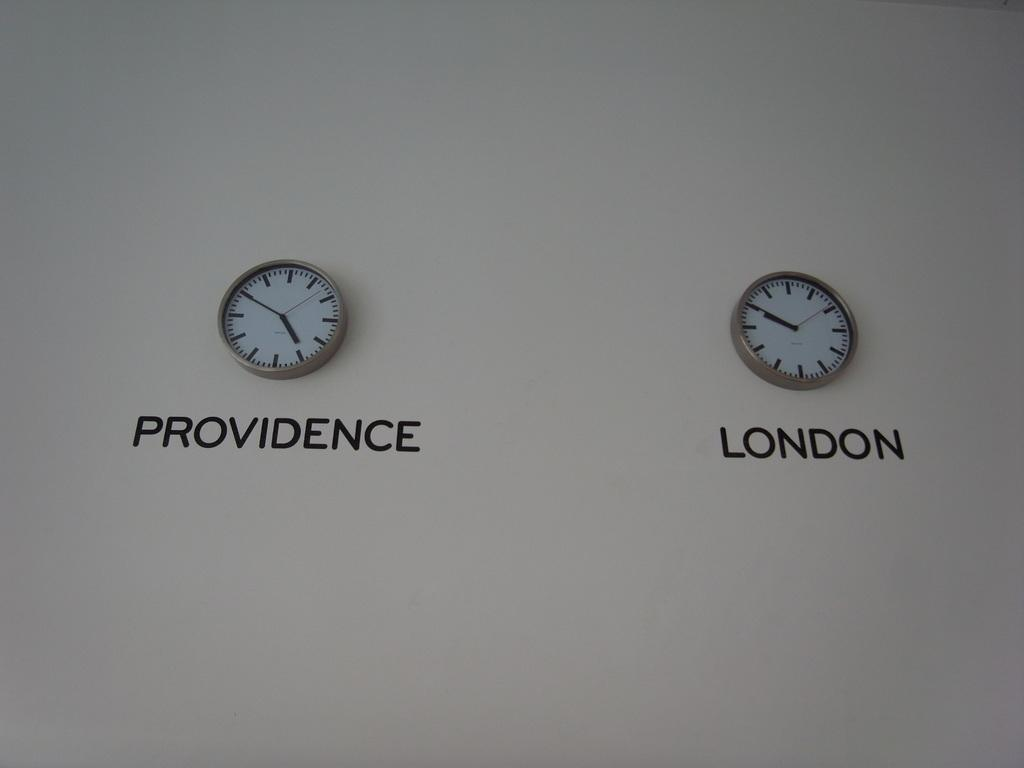Provide a one-sentence caption for the provided image. Two similar clocks one from providencce and one from london. 